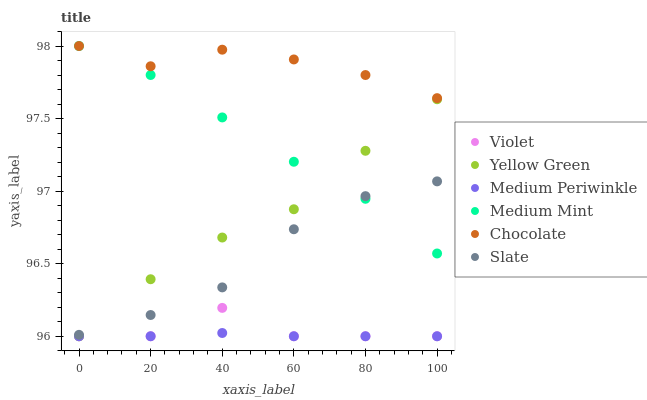Does Medium Periwinkle have the minimum area under the curve?
Answer yes or no. Yes. Does Chocolate have the maximum area under the curve?
Answer yes or no. Yes. Does Yellow Green have the minimum area under the curve?
Answer yes or no. No. Does Yellow Green have the maximum area under the curve?
Answer yes or no. No. Is Medium Periwinkle the smoothest?
Answer yes or no. Yes. Is Violet the roughest?
Answer yes or no. Yes. Is Yellow Green the smoothest?
Answer yes or no. No. Is Yellow Green the roughest?
Answer yes or no. No. Does Yellow Green have the lowest value?
Answer yes or no. Yes. Does Slate have the lowest value?
Answer yes or no. No. Does Chocolate have the highest value?
Answer yes or no. Yes. Does Yellow Green have the highest value?
Answer yes or no. No. Is Violet less than Chocolate?
Answer yes or no. Yes. Is Chocolate greater than Medium Periwinkle?
Answer yes or no. Yes. Does Yellow Green intersect Slate?
Answer yes or no. Yes. Is Yellow Green less than Slate?
Answer yes or no. No. Is Yellow Green greater than Slate?
Answer yes or no. No. Does Violet intersect Chocolate?
Answer yes or no. No. 